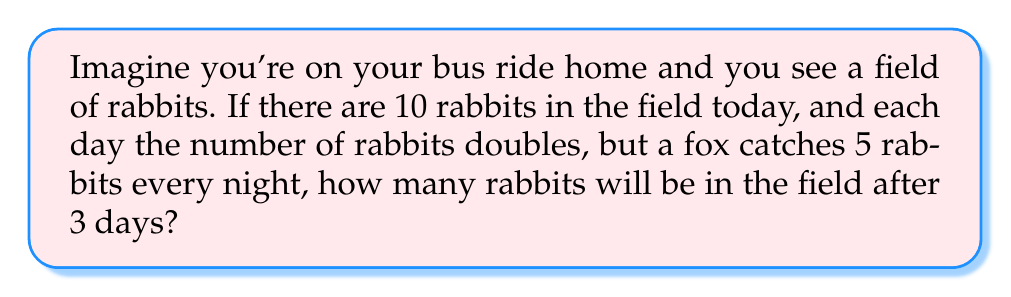Provide a solution to this math problem. Let's solve this step-by-step:

1. Start with 10 rabbits on day 0.

2. Day 1:
   - Rabbits double: $10 \times 2 = 20$
   - Fox catches 5: $20 - 5 = 15$
   - End of day 1: 15 rabbits

3. Day 2:
   - Rabbits double: $15 \times 2 = 30$
   - Fox catches 5: $30 - 5 = 25$
   - End of day 2: 25 rabbits

4. Day 3:
   - Rabbits double: $25 \times 2 = 50$
   - Fox catches 5: $50 - 5 = 45$
   - End of day 3: 45 rabbits

We can represent this process mathematically as:

$$R_{n+1} = 2R_n - 5$$

Where $R_n$ is the number of rabbits on day $n$.

This is a simple example of a chaotic system. Even though the rule is simple, the population grows in a way that might seem unexpected at first glance.
Answer: 45 rabbits 